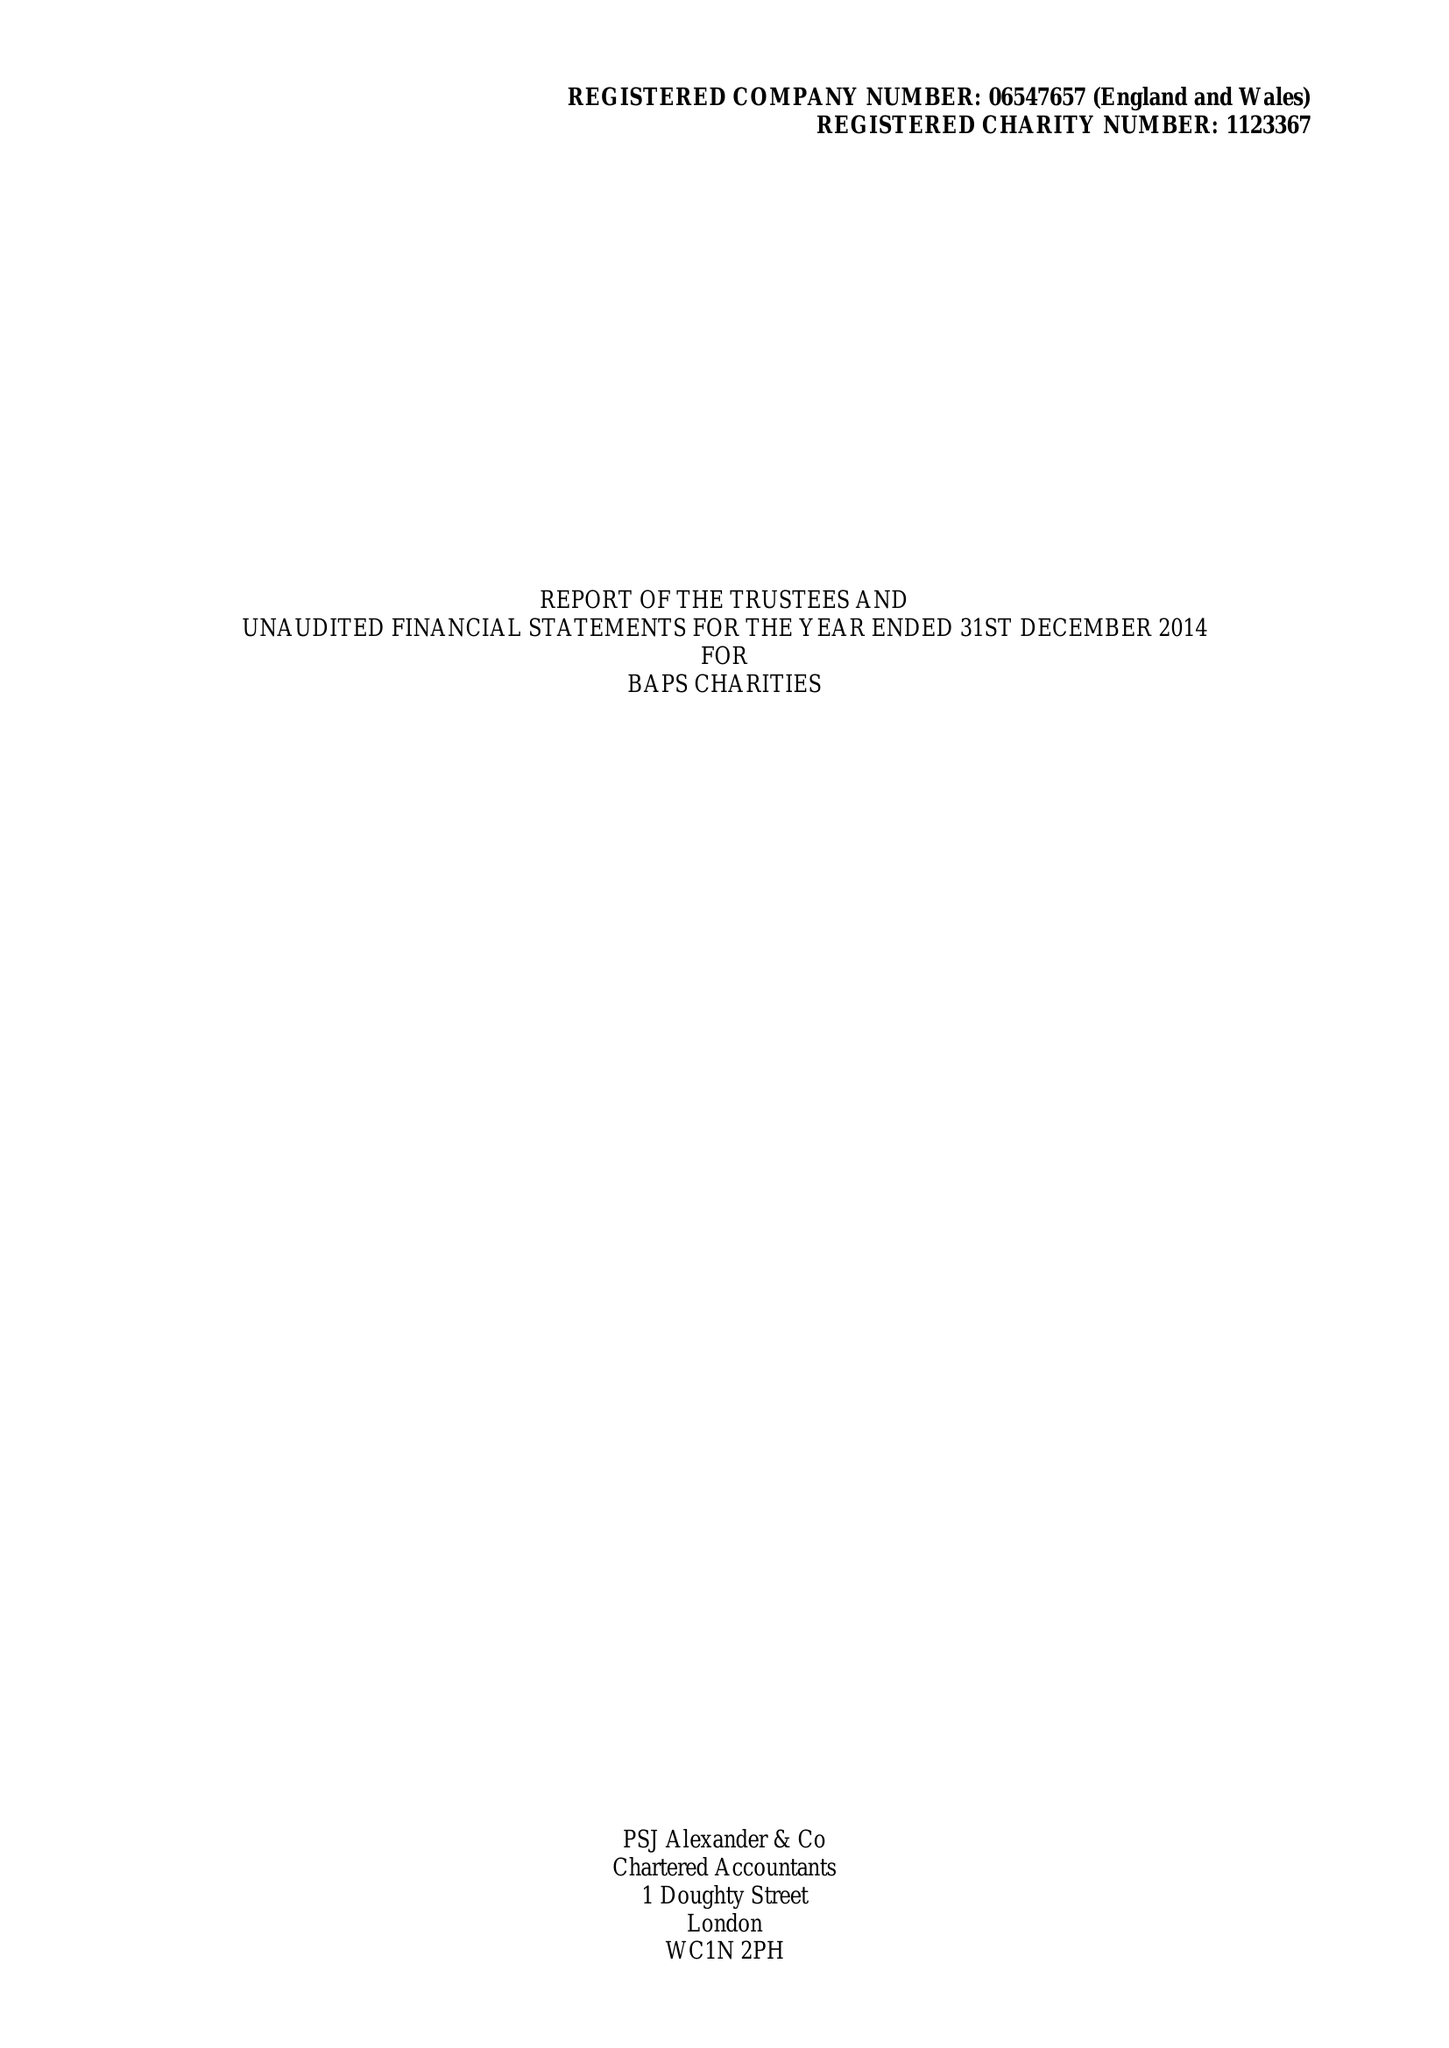What is the value for the report_date?
Answer the question using a single word or phrase. 2014-12-31 